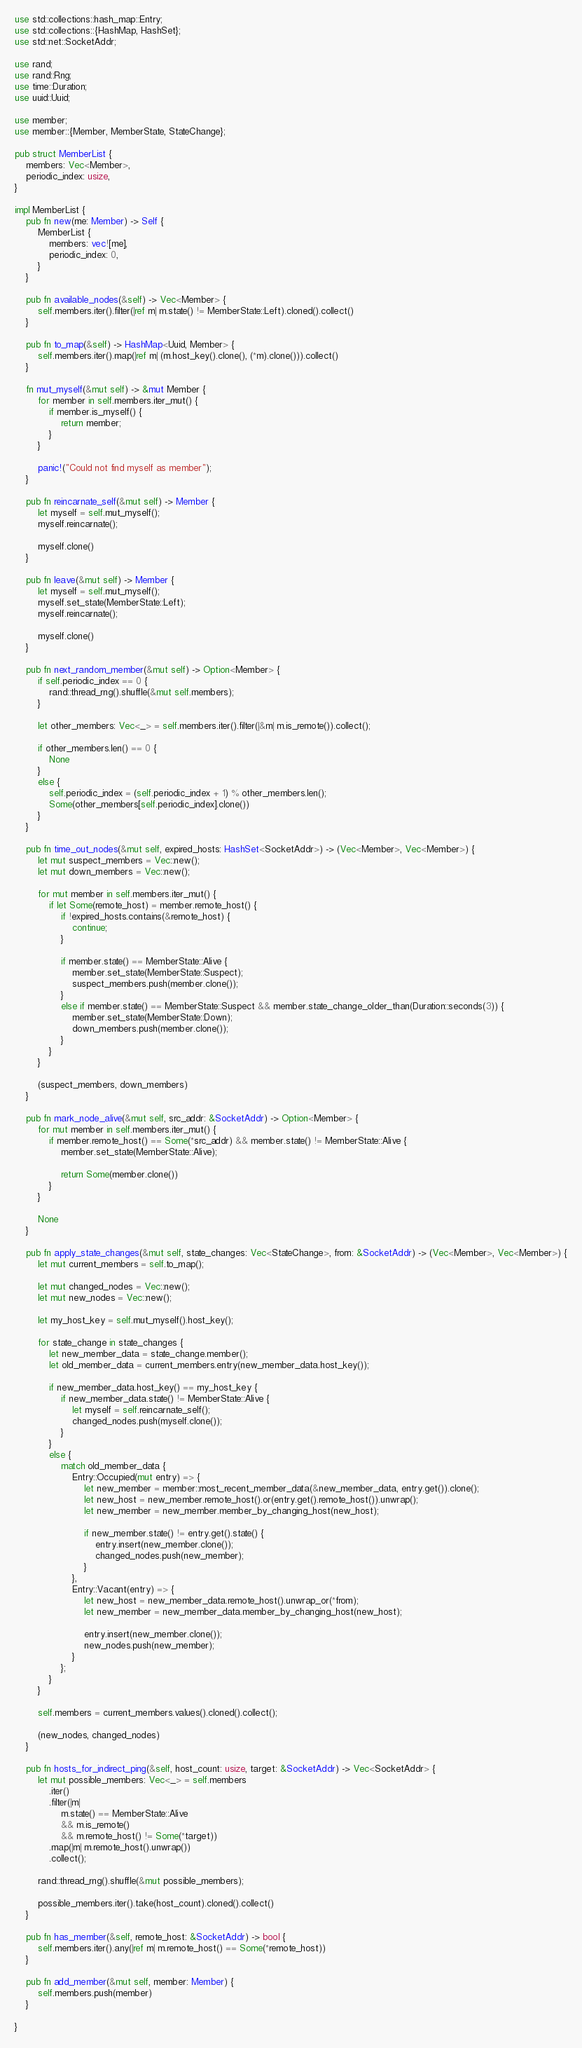Convert code to text. <code><loc_0><loc_0><loc_500><loc_500><_Rust_>use std::collections::hash_map::Entry;
use std::collections::{HashMap, HashSet};
use std::net::SocketAddr;

use rand;
use rand::Rng;
use time::Duration;
use uuid::Uuid;

use member;
use member::{Member, MemberState, StateChange};

pub struct MemberList {
    members: Vec<Member>,
    periodic_index: usize,
}

impl MemberList {
    pub fn new(me: Member) -> Self {
        MemberList {
            members: vec![me],
            periodic_index: 0,
        }
    }

    pub fn available_nodes(&self) -> Vec<Member> {
        self.members.iter().filter(|ref m| m.state() != MemberState::Left).cloned().collect()
    }

    pub fn to_map(&self) -> HashMap<Uuid, Member> {
        self.members.iter().map(|ref m| (m.host_key().clone(), (*m).clone())).collect()
    }

    fn mut_myself(&mut self) -> &mut Member {
        for member in self.members.iter_mut() {
            if member.is_myself() {
                return member;
            }
        }

        panic!("Could not find myself as member");
    }

    pub fn reincarnate_self(&mut self) -> Member {
        let myself = self.mut_myself();
        myself.reincarnate();

        myself.clone()
    }

    pub fn leave(&mut self) -> Member {
        let myself = self.mut_myself();
        myself.set_state(MemberState::Left);
        myself.reincarnate();

        myself.clone()
    }

    pub fn next_random_member(&mut self) -> Option<Member> {
        if self.periodic_index == 0 {
            rand::thread_rng().shuffle(&mut self.members);
        }

        let other_members: Vec<_> = self.members.iter().filter(|&m| m.is_remote()).collect();

        if other_members.len() == 0 {
            None
        }
        else {
            self.periodic_index = (self.periodic_index + 1) % other_members.len();
            Some(other_members[self.periodic_index].clone())
        }
    }

    pub fn time_out_nodes(&mut self, expired_hosts: HashSet<SocketAddr>) -> (Vec<Member>, Vec<Member>) {
        let mut suspect_members = Vec::new();
        let mut down_members = Vec::new();

        for mut member in self.members.iter_mut() {
            if let Some(remote_host) = member.remote_host() {
                if !expired_hosts.contains(&remote_host) {
                    continue;
                }

                if member.state() == MemberState::Alive {
                    member.set_state(MemberState::Suspect);
                    suspect_members.push(member.clone());
                }
                else if member.state() == MemberState::Suspect && member.state_change_older_than(Duration::seconds(3)) {
                    member.set_state(MemberState::Down);
                    down_members.push(member.clone());
                }
            }
        }

        (suspect_members, down_members)
    }

    pub fn mark_node_alive(&mut self, src_addr: &SocketAddr) -> Option<Member> {
        for mut member in self.members.iter_mut() {
            if member.remote_host() == Some(*src_addr) && member.state() != MemberState::Alive {
                member.set_state(MemberState::Alive);

                return Some(member.clone())
            }
        }

        None
    }

    pub fn apply_state_changes(&mut self, state_changes: Vec<StateChange>, from: &SocketAddr) -> (Vec<Member>, Vec<Member>) {
        let mut current_members = self.to_map();

        let mut changed_nodes = Vec::new();
        let mut new_nodes = Vec::new();

        let my_host_key = self.mut_myself().host_key();

        for state_change in state_changes {
            let new_member_data = state_change.member();
            let old_member_data = current_members.entry(new_member_data.host_key());

            if new_member_data.host_key() == my_host_key {
                if new_member_data.state() != MemberState::Alive {
                    let myself = self.reincarnate_self();
                    changed_nodes.push(myself.clone());
                }
            }
            else {
                match old_member_data {
                    Entry::Occupied(mut entry) => {
                        let new_member = member::most_recent_member_data(&new_member_data, entry.get()).clone();
                        let new_host = new_member.remote_host().or(entry.get().remote_host()).unwrap();
                        let new_member = new_member.member_by_changing_host(new_host);

                        if new_member.state() != entry.get().state() {
                            entry.insert(new_member.clone());
                            changed_nodes.push(new_member);
                        }
                    },
                    Entry::Vacant(entry) => {
                        let new_host = new_member_data.remote_host().unwrap_or(*from);
                        let new_member = new_member_data.member_by_changing_host(new_host);

                        entry.insert(new_member.clone());
                        new_nodes.push(new_member);
                    }
                };
            }
        }

        self.members = current_members.values().cloned().collect();

        (new_nodes, changed_nodes)
    }

    pub fn hosts_for_indirect_ping(&self, host_count: usize, target: &SocketAddr) -> Vec<SocketAddr> {
        let mut possible_members: Vec<_> = self.members
            .iter()
            .filter(|m|
                m.state() == MemberState::Alive
                && m.is_remote()
                && m.remote_host() != Some(*target))
            .map(|m| m.remote_host().unwrap())
            .collect();

        rand::thread_rng().shuffle(&mut possible_members);

        possible_members.iter().take(host_count).cloned().collect()
    }

    pub fn has_member(&self, remote_host: &SocketAddr) -> bool {
        self.members.iter().any(|ref m| m.remote_host() == Some(*remote_host))
    }

    pub fn add_member(&mut self, member: Member) {
        self.members.push(member)
    }

}
</code> 